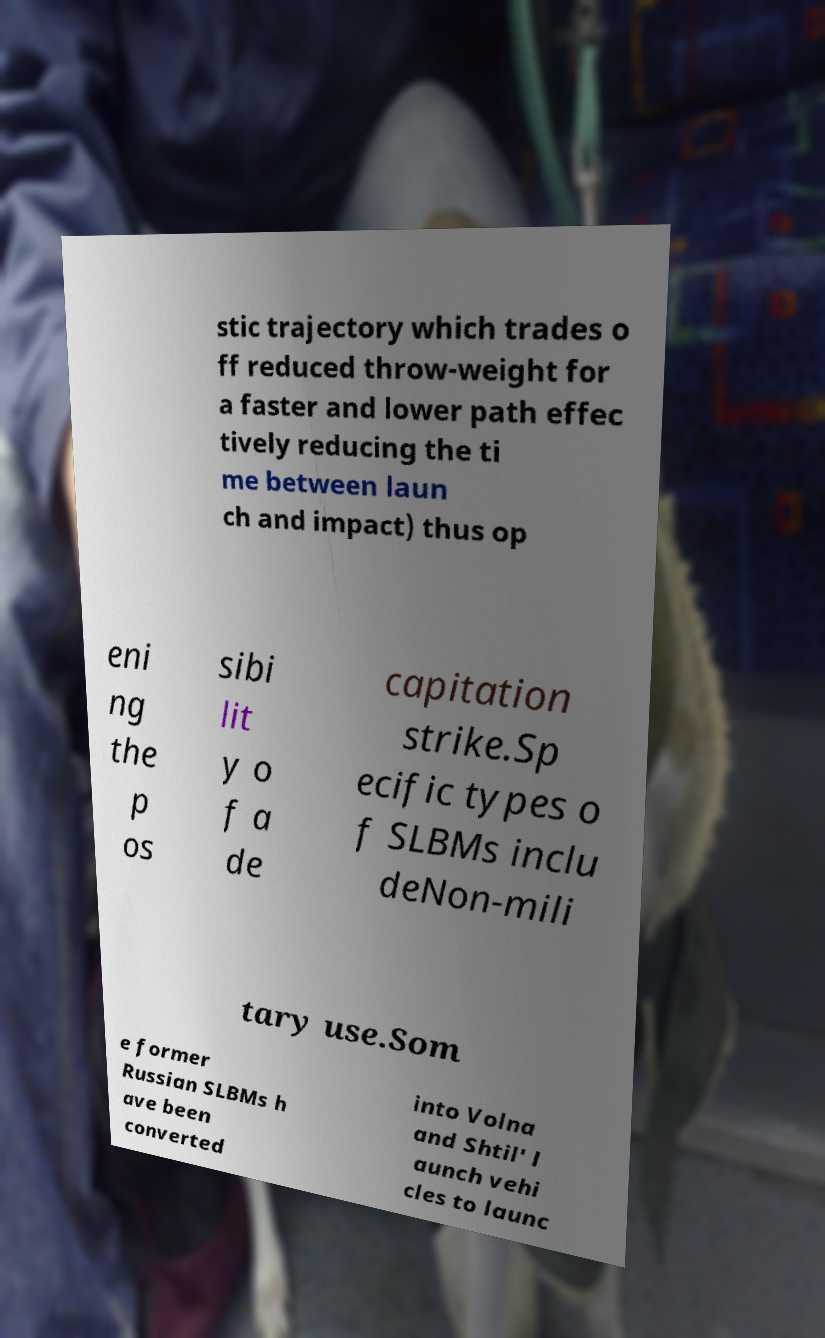What messages or text are displayed in this image? I need them in a readable, typed format. stic trajectory which trades o ff reduced throw-weight for a faster and lower path effec tively reducing the ti me between laun ch and impact) thus op eni ng the p os sibi lit y o f a de capitation strike.Sp ecific types o f SLBMs inclu deNon-mili tary use.Som e former Russian SLBMs h ave been converted into Volna and Shtil' l aunch vehi cles to launc 